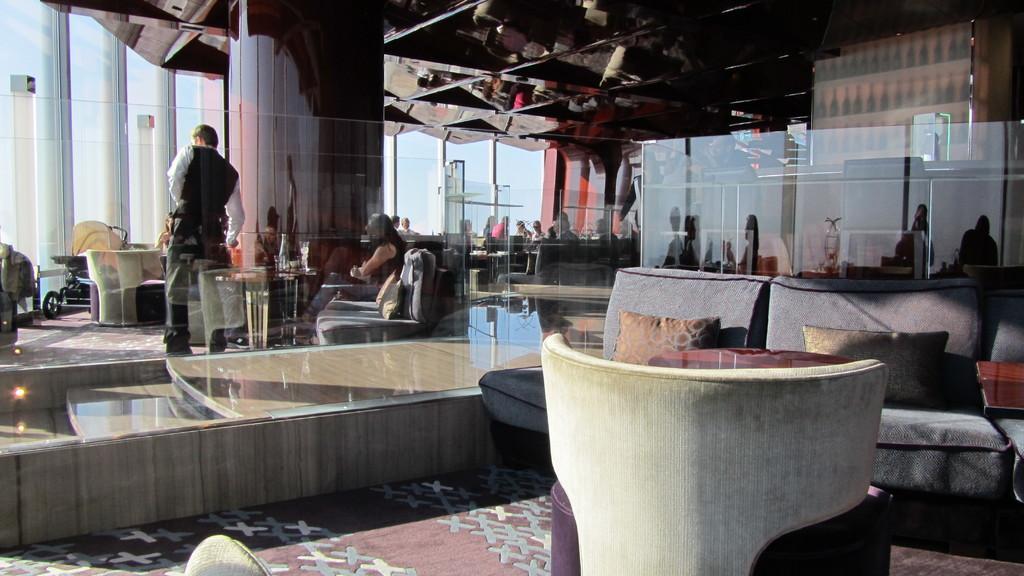In one or two sentences, can you explain what this image depicts? In this image I can see the couch and the glass. To the back side of the glass there are few people sitting and one person standing. 